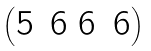Convert formula to latex. <formula><loc_0><loc_0><loc_500><loc_500>\begin{pmatrix} 5 & 6 \ 6 & 6 \end{pmatrix}</formula> 